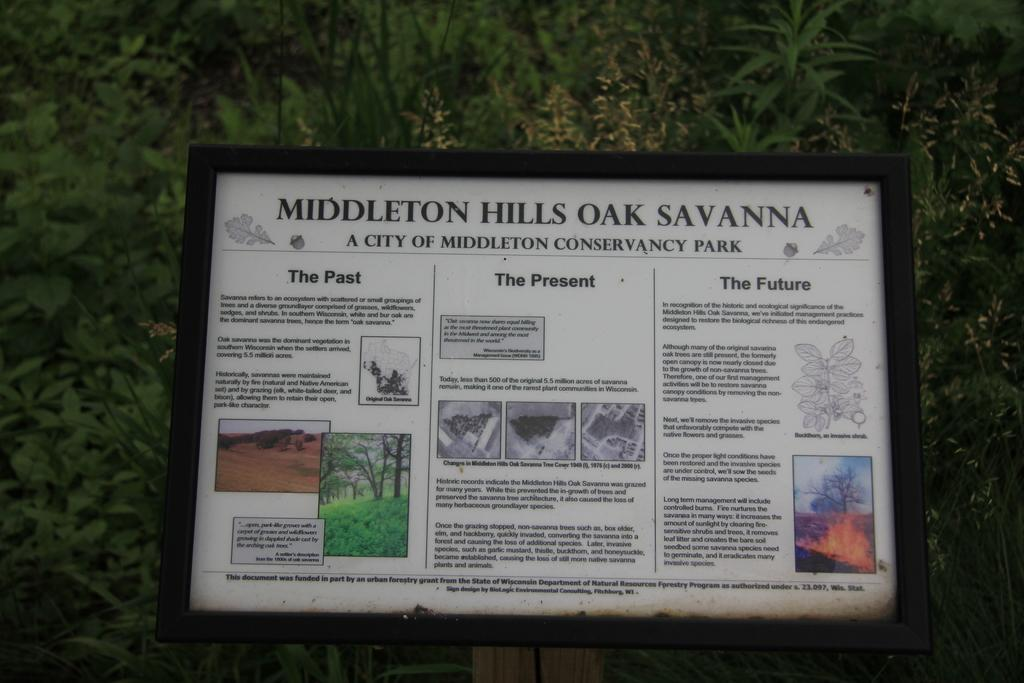What is the main subject in the middle of the image? There is a poster in the middle of the image. What can be seen on the poster? The poster has images and black color texts. How is the poster displayed? The poster is in a frame and attached to a pole. What is visible in the background of the image? There are trees in the background of the image. How many feet are visible in the image? There are no feet visible in the image; it primarily features a poster. What type of division is being taught in the image? There is no indication of any division being taught or discussed in the image. 